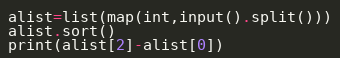<code> <loc_0><loc_0><loc_500><loc_500><_Python_>alist=list(map(int,input().split()))
alist.sort()
print(alist[2]-alist[0])</code> 